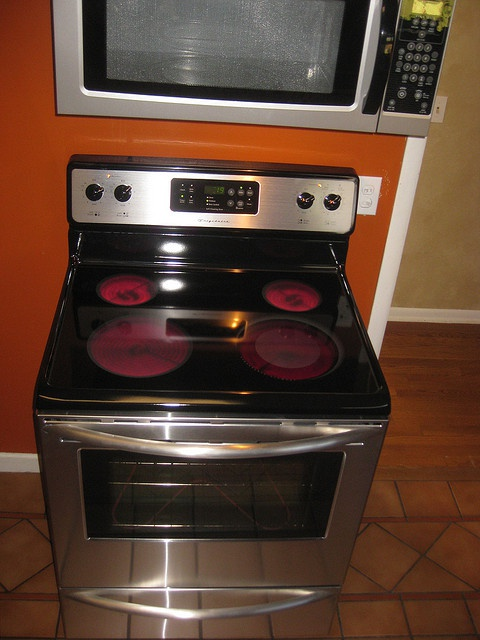Describe the objects in this image and their specific colors. I can see oven in maroon, black, gray, and white tones and microwave in maroon, gray, black, and darkgray tones in this image. 